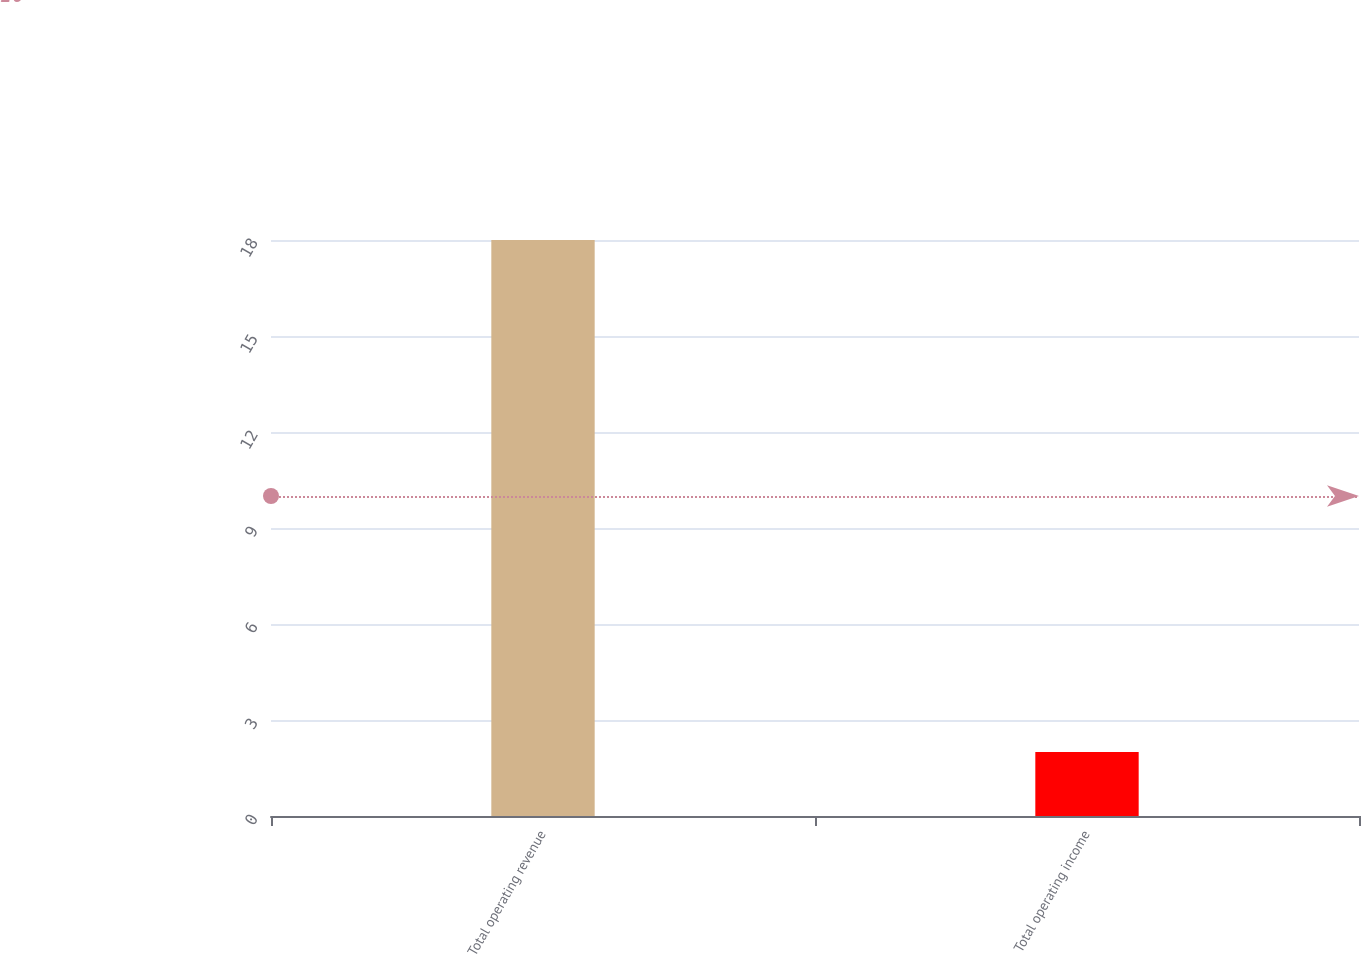Convert chart. <chart><loc_0><loc_0><loc_500><loc_500><bar_chart><fcel>Total operating revenue<fcel>Total operating income<nl><fcel>18<fcel>2<nl></chart> 